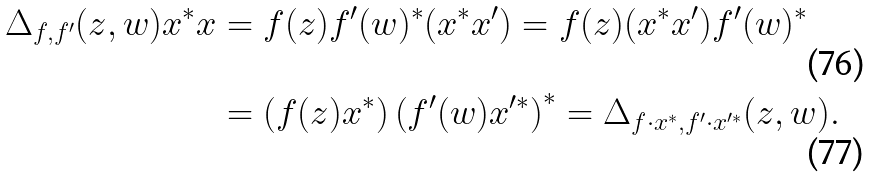Convert formula to latex. <formula><loc_0><loc_0><loc_500><loc_500>\Delta _ { f , f ^ { \prime } } ( z , w ) x ^ { * } x & = f ( z ) f ^ { \prime } ( w ) ^ { * } ( x ^ { * } x ^ { \prime } ) = f ( z ) ( x ^ { * } x ^ { \prime } ) f ^ { \prime } ( w ) ^ { * } \\ & = \left ( f ( z ) x ^ { * } \right ) \left ( f ^ { \prime } ( w ) x ^ { \prime * } \right ) ^ { * } = \Delta _ { f \cdot x ^ { * } , f ^ { \prime } \cdot x ^ { \prime * } } ( z , w ) .</formula> 